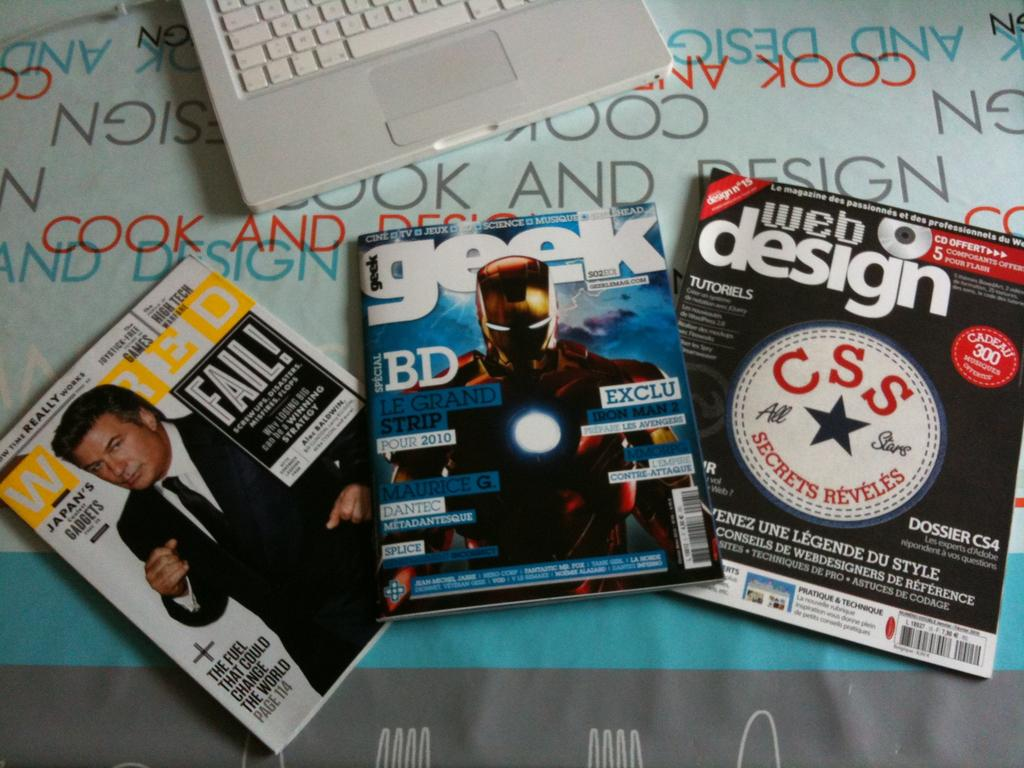<image>
Present a compact description of the photo's key features. magazines like GEEK and WEB Design are on display 